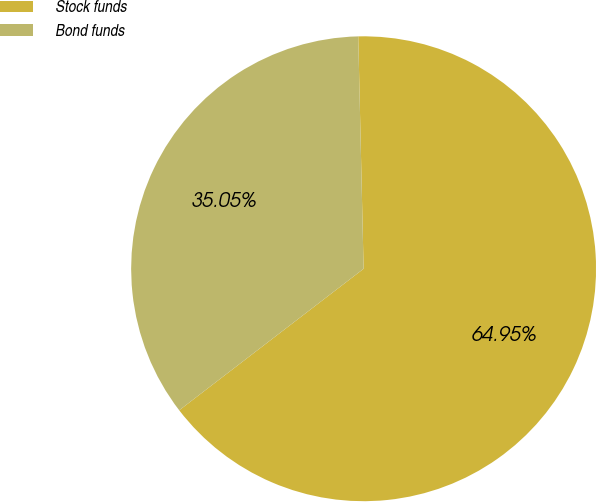<chart> <loc_0><loc_0><loc_500><loc_500><pie_chart><fcel>Stock funds<fcel>Bond funds<nl><fcel>64.95%<fcel>35.05%<nl></chart> 